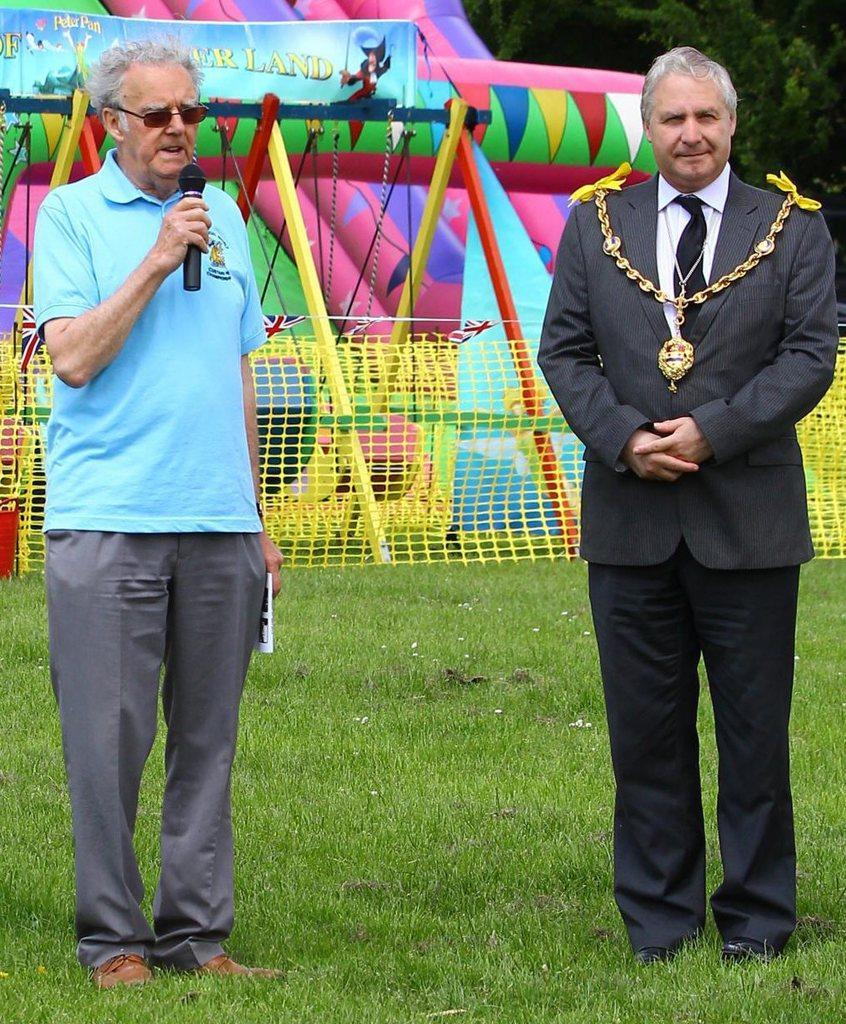How would you summarize this image in a sentence or two? In this picture we can see old man wearing blue color t- shirt standing in the grass lawn and giving a speech in the microphone. Beside we can see another man wearing black color coat standing and giving a pose into the camera. Behind we can see kids playing zone. 